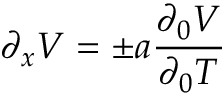Convert formula to latex. <formula><loc_0><loc_0><loc_500><loc_500>\partial _ { x } V = \pm a { \frac { \partial _ { 0 } V } { \partial _ { 0 } T } }</formula> 